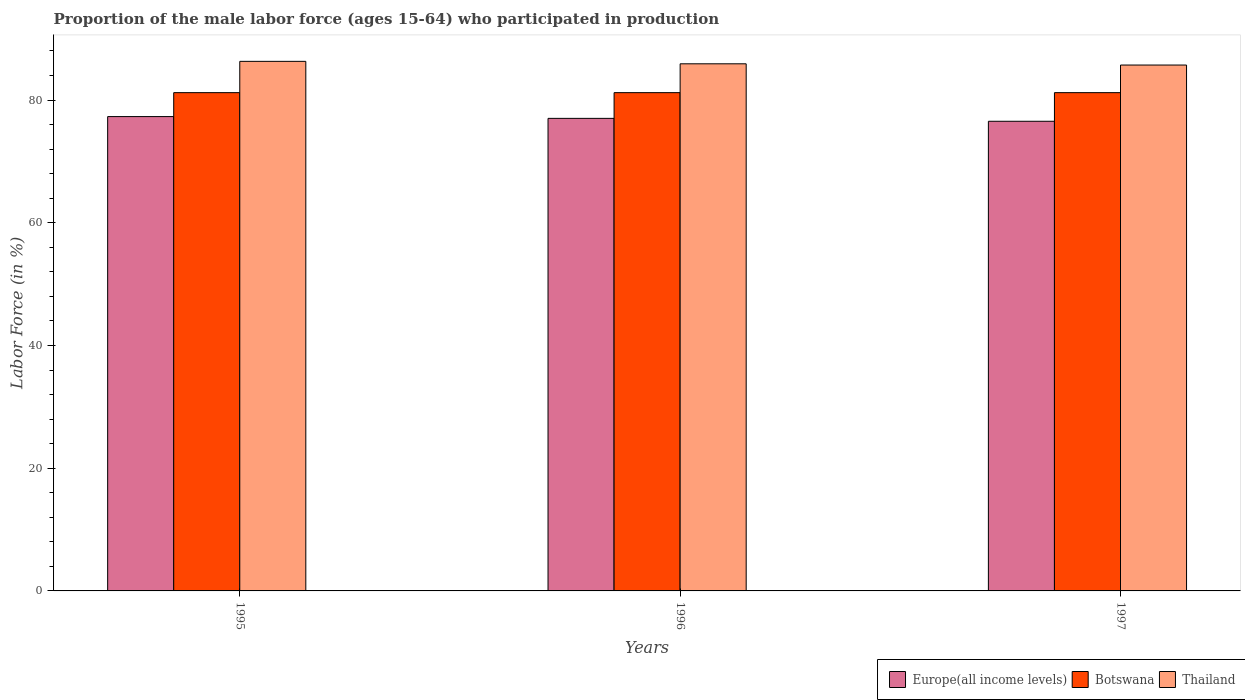How many groups of bars are there?
Your answer should be compact. 3. Are the number of bars per tick equal to the number of legend labels?
Your answer should be very brief. Yes. Are the number of bars on each tick of the X-axis equal?
Offer a very short reply. Yes. What is the proportion of the male labor force who participated in production in Thailand in 1996?
Make the answer very short. 85.9. Across all years, what is the maximum proportion of the male labor force who participated in production in Thailand?
Keep it short and to the point. 86.3. Across all years, what is the minimum proportion of the male labor force who participated in production in Botswana?
Provide a succinct answer. 81.2. In which year was the proportion of the male labor force who participated in production in Thailand minimum?
Offer a terse response. 1997. What is the total proportion of the male labor force who participated in production in Botswana in the graph?
Your answer should be very brief. 243.6. What is the difference between the proportion of the male labor force who participated in production in Thailand in 1995 and that in 1996?
Your response must be concise. 0.4. What is the difference between the proportion of the male labor force who participated in production in Botswana in 1996 and the proportion of the male labor force who participated in production in Europe(all income levels) in 1995?
Ensure brevity in your answer.  3.9. What is the average proportion of the male labor force who participated in production in Europe(all income levels) per year?
Give a very brief answer. 76.95. In the year 1996, what is the difference between the proportion of the male labor force who participated in production in Thailand and proportion of the male labor force who participated in production in Botswana?
Make the answer very short. 4.7. What is the difference between the highest and the second highest proportion of the male labor force who participated in production in Europe(all income levels)?
Provide a short and direct response. 0.29. Is the sum of the proportion of the male labor force who participated in production in Botswana in 1996 and 1997 greater than the maximum proportion of the male labor force who participated in production in Europe(all income levels) across all years?
Offer a very short reply. Yes. What does the 1st bar from the left in 1995 represents?
Give a very brief answer. Europe(all income levels). What does the 1st bar from the right in 1996 represents?
Your answer should be very brief. Thailand. Is it the case that in every year, the sum of the proportion of the male labor force who participated in production in Thailand and proportion of the male labor force who participated in production in Europe(all income levels) is greater than the proportion of the male labor force who participated in production in Botswana?
Give a very brief answer. Yes. Are all the bars in the graph horizontal?
Ensure brevity in your answer.  No. What is the difference between two consecutive major ticks on the Y-axis?
Your answer should be compact. 20. Are the values on the major ticks of Y-axis written in scientific E-notation?
Provide a short and direct response. No. Does the graph contain any zero values?
Your answer should be compact. No. Where does the legend appear in the graph?
Give a very brief answer. Bottom right. How many legend labels are there?
Provide a short and direct response. 3. What is the title of the graph?
Offer a terse response. Proportion of the male labor force (ages 15-64) who participated in production. What is the label or title of the X-axis?
Keep it short and to the point. Years. What is the Labor Force (in %) of Europe(all income levels) in 1995?
Offer a very short reply. 77.3. What is the Labor Force (in %) in Botswana in 1995?
Offer a terse response. 81.2. What is the Labor Force (in %) in Thailand in 1995?
Offer a terse response. 86.3. What is the Labor Force (in %) in Europe(all income levels) in 1996?
Make the answer very short. 77.01. What is the Labor Force (in %) of Botswana in 1996?
Keep it short and to the point. 81.2. What is the Labor Force (in %) of Thailand in 1996?
Keep it short and to the point. 85.9. What is the Labor Force (in %) in Europe(all income levels) in 1997?
Offer a terse response. 76.54. What is the Labor Force (in %) in Botswana in 1997?
Give a very brief answer. 81.2. What is the Labor Force (in %) in Thailand in 1997?
Your answer should be very brief. 85.7. Across all years, what is the maximum Labor Force (in %) of Europe(all income levels)?
Your answer should be very brief. 77.3. Across all years, what is the maximum Labor Force (in %) in Botswana?
Offer a terse response. 81.2. Across all years, what is the maximum Labor Force (in %) of Thailand?
Your response must be concise. 86.3. Across all years, what is the minimum Labor Force (in %) of Europe(all income levels)?
Your response must be concise. 76.54. Across all years, what is the minimum Labor Force (in %) in Botswana?
Your response must be concise. 81.2. Across all years, what is the minimum Labor Force (in %) in Thailand?
Your response must be concise. 85.7. What is the total Labor Force (in %) of Europe(all income levels) in the graph?
Offer a very short reply. 230.84. What is the total Labor Force (in %) in Botswana in the graph?
Offer a terse response. 243.6. What is the total Labor Force (in %) of Thailand in the graph?
Make the answer very short. 257.9. What is the difference between the Labor Force (in %) of Europe(all income levels) in 1995 and that in 1996?
Provide a short and direct response. 0.29. What is the difference between the Labor Force (in %) in Thailand in 1995 and that in 1996?
Provide a short and direct response. 0.4. What is the difference between the Labor Force (in %) in Europe(all income levels) in 1995 and that in 1997?
Your response must be concise. 0.76. What is the difference between the Labor Force (in %) of Thailand in 1995 and that in 1997?
Ensure brevity in your answer.  0.6. What is the difference between the Labor Force (in %) of Europe(all income levels) in 1996 and that in 1997?
Make the answer very short. 0.47. What is the difference between the Labor Force (in %) of Europe(all income levels) in 1995 and the Labor Force (in %) of Botswana in 1996?
Ensure brevity in your answer.  -3.9. What is the difference between the Labor Force (in %) in Europe(all income levels) in 1995 and the Labor Force (in %) in Thailand in 1996?
Give a very brief answer. -8.6. What is the difference between the Labor Force (in %) of Botswana in 1995 and the Labor Force (in %) of Thailand in 1996?
Give a very brief answer. -4.7. What is the difference between the Labor Force (in %) of Europe(all income levels) in 1995 and the Labor Force (in %) of Botswana in 1997?
Your answer should be compact. -3.9. What is the difference between the Labor Force (in %) of Europe(all income levels) in 1995 and the Labor Force (in %) of Thailand in 1997?
Offer a terse response. -8.4. What is the difference between the Labor Force (in %) of Europe(all income levels) in 1996 and the Labor Force (in %) of Botswana in 1997?
Keep it short and to the point. -4.19. What is the difference between the Labor Force (in %) of Europe(all income levels) in 1996 and the Labor Force (in %) of Thailand in 1997?
Offer a terse response. -8.69. What is the difference between the Labor Force (in %) of Botswana in 1996 and the Labor Force (in %) of Thailand in 1997?
Provide a short and direct response. -4.5. What is the average Labor Force (in %) of Europe(all income levels) per year?
Ensure brevity in your answer.  76.95. What is the average Labor Force (in %) in Botswana per year?
Your answer should be compact. 81.2. What is the average Labor Force (in %) of Thailand per year?
Offer a terse response. 85.97. In the year 1995, what is the difference between the Labor Force (in %) of Europe(all income levels) and Labor Force (in %) of Botswana?
Your answer should be very brief. -3.9. In the year 1995, what is the difference between the Labor Force (in %) in Europe(all income levels) and Labor Force (in %) in Thailand?
Your answer should be very brief. -9. In the year 1995, what is the difference between the Labor Force (in %) of Botswana and Labor Force (in %) of Thailand?
Provide a succinct answer. -5.1. In the year 1996, what is the difference between the Labor Force (in %) of Europe(all income levels) and Labor Force (in %) of Botswana?
Your response must be concise. -4.19. In the year 1996, what is the difference between the Labor Force (in %) of Europe(all income levels) and Labor Force (in %) of Thailand?
Provide a short and direct response. -8.89. In the year 1996, what is the difference between the Labor Force (in %) in Botswana and Labor Force (in %) in Thailand?
Make the answer very short. -4.7. In the year 1997, what is the difference between the Labor Force (in %) of Europe(all income levels) and Labor Force (in %) of Botswana?
Your answer should be compact. -4.66. In the year 1997, what is the difference between the Labor Force (in %) in Europe(all income levels) and Labor Force (in %) in Thailand?
Ensure brevity in your answer.  -9.16. What is the ratio of the Labor Force (in %) in Europe(all income levels) in 1995 to that in 1996?
Provide a short and direct response. 1. What is the ratio of the Labor Force (in %) in Thailand in 1995 to that in 1996?
Offer a very short reply. 1. What is the ratio of the Labor Force (in %) of Botswana in 1995 to that in 1997?
Provide a succinct answer. 1. What is the ratio of the Labor Force (in %) in Thailand in 1995 to that in 1997?
Keep it short and to the point. 1.01. What is the ratio of the Labor Force (in %) of Thailand in 1996 to that in 1997?
Make the answer very short. 1. What is the difference between the highest and the second highest Labor Force (in %) in Europe(all income levels)?
Provide a short and direct response. 0.29. What is the difference between the highest and the second highest Labor Force (in %) of Botswana?
Give a very brief answer. 0. What is the difference between the highest and the second highest Labor Force (in %) of Thailand?
Provide a short and direct response. 0.4. What is the difference between the highest and the lowest Labor Force (in %) of Europe(all income levels)?
Provide a short and direct response. 0.76. What is the difference between the highest and the lowest Labor Force (in %) in Thailand?
Ensure brevity in your answer.  0.6. 